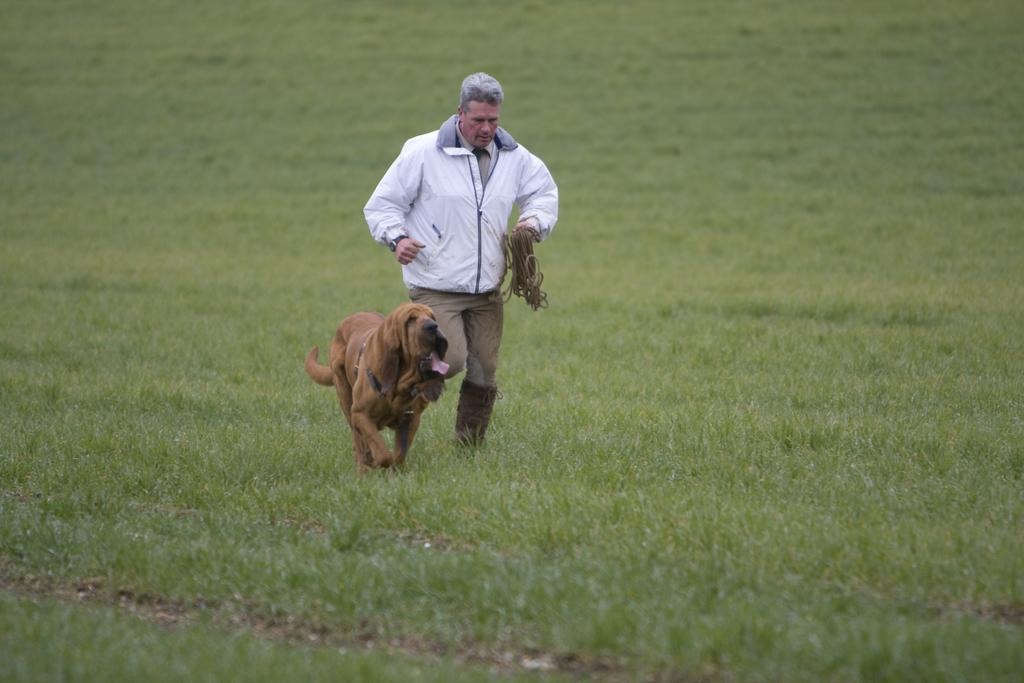Who or what can be seen in the image besides the man? There is a dog in the image. What are the man and the dog doing in the image? The man and the dog are running. What is the color of the ground in the image? The ground is green in color, as it is grass. What is the man holding in the image? The man is holding a rope. What type of clothing is the man wearing on his upper body? The man is wearing a jerkin. What type of clothing is the man wearing on his lower body? The man is wearing trousers. What type of footwear is the man wearing in the image? The man is wearing shoes. How many rail tracks can be seen in the image? There are no rail tracks present in the image. What type of giants can be seen in the image? There are no giants present in the image. 